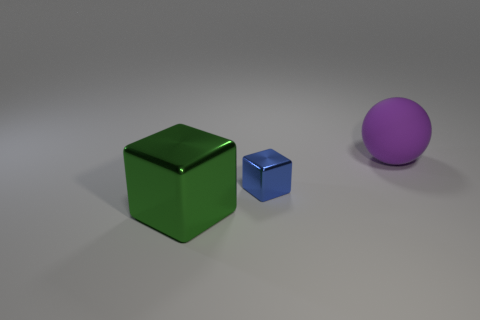Add 1 big shiny cubes. How many objects exist? 4 Subtract all blocks. How many objects are left? 1 Add 2 large metallic spheres. How many large metallic spheres exist? 2 Subtract 0 brown balls. How many objects are left? 3 Subtract all tiny blue balls. Subtract all big metallic cubes. How many objects are left? 2 Add 3 blocks. How many blocks are left? 5 